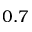<formula> <loc_0><loc_0><loc_500><loc_500>0 . 7</formula> 